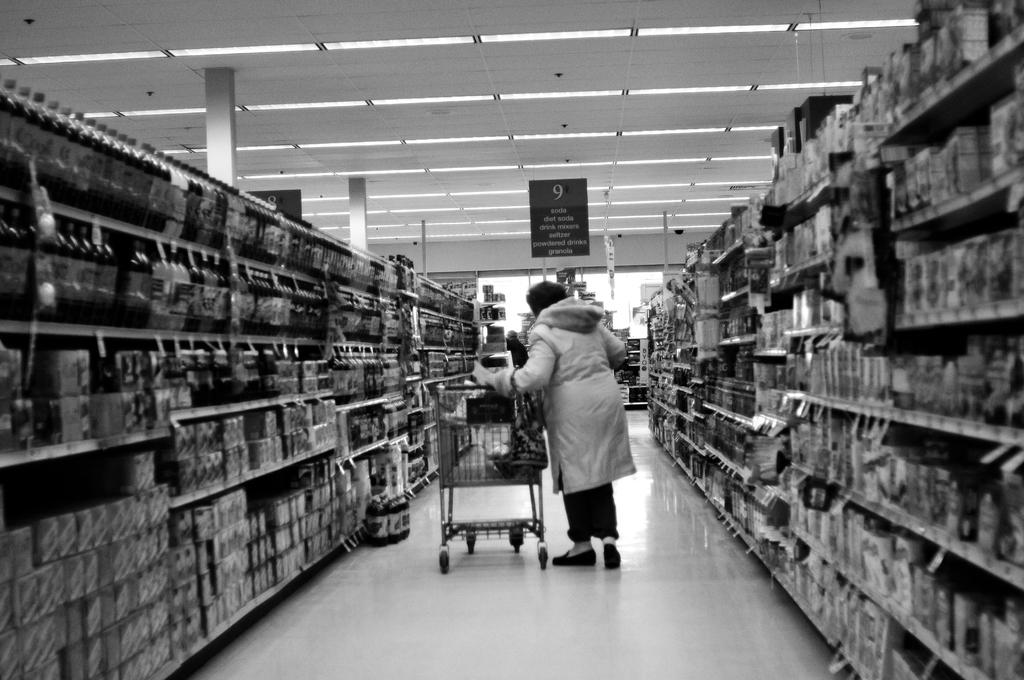<image>
Relay a brief, clear account of the picture shown. A woman walks down grocery store aisle number 9 where the soda is. 